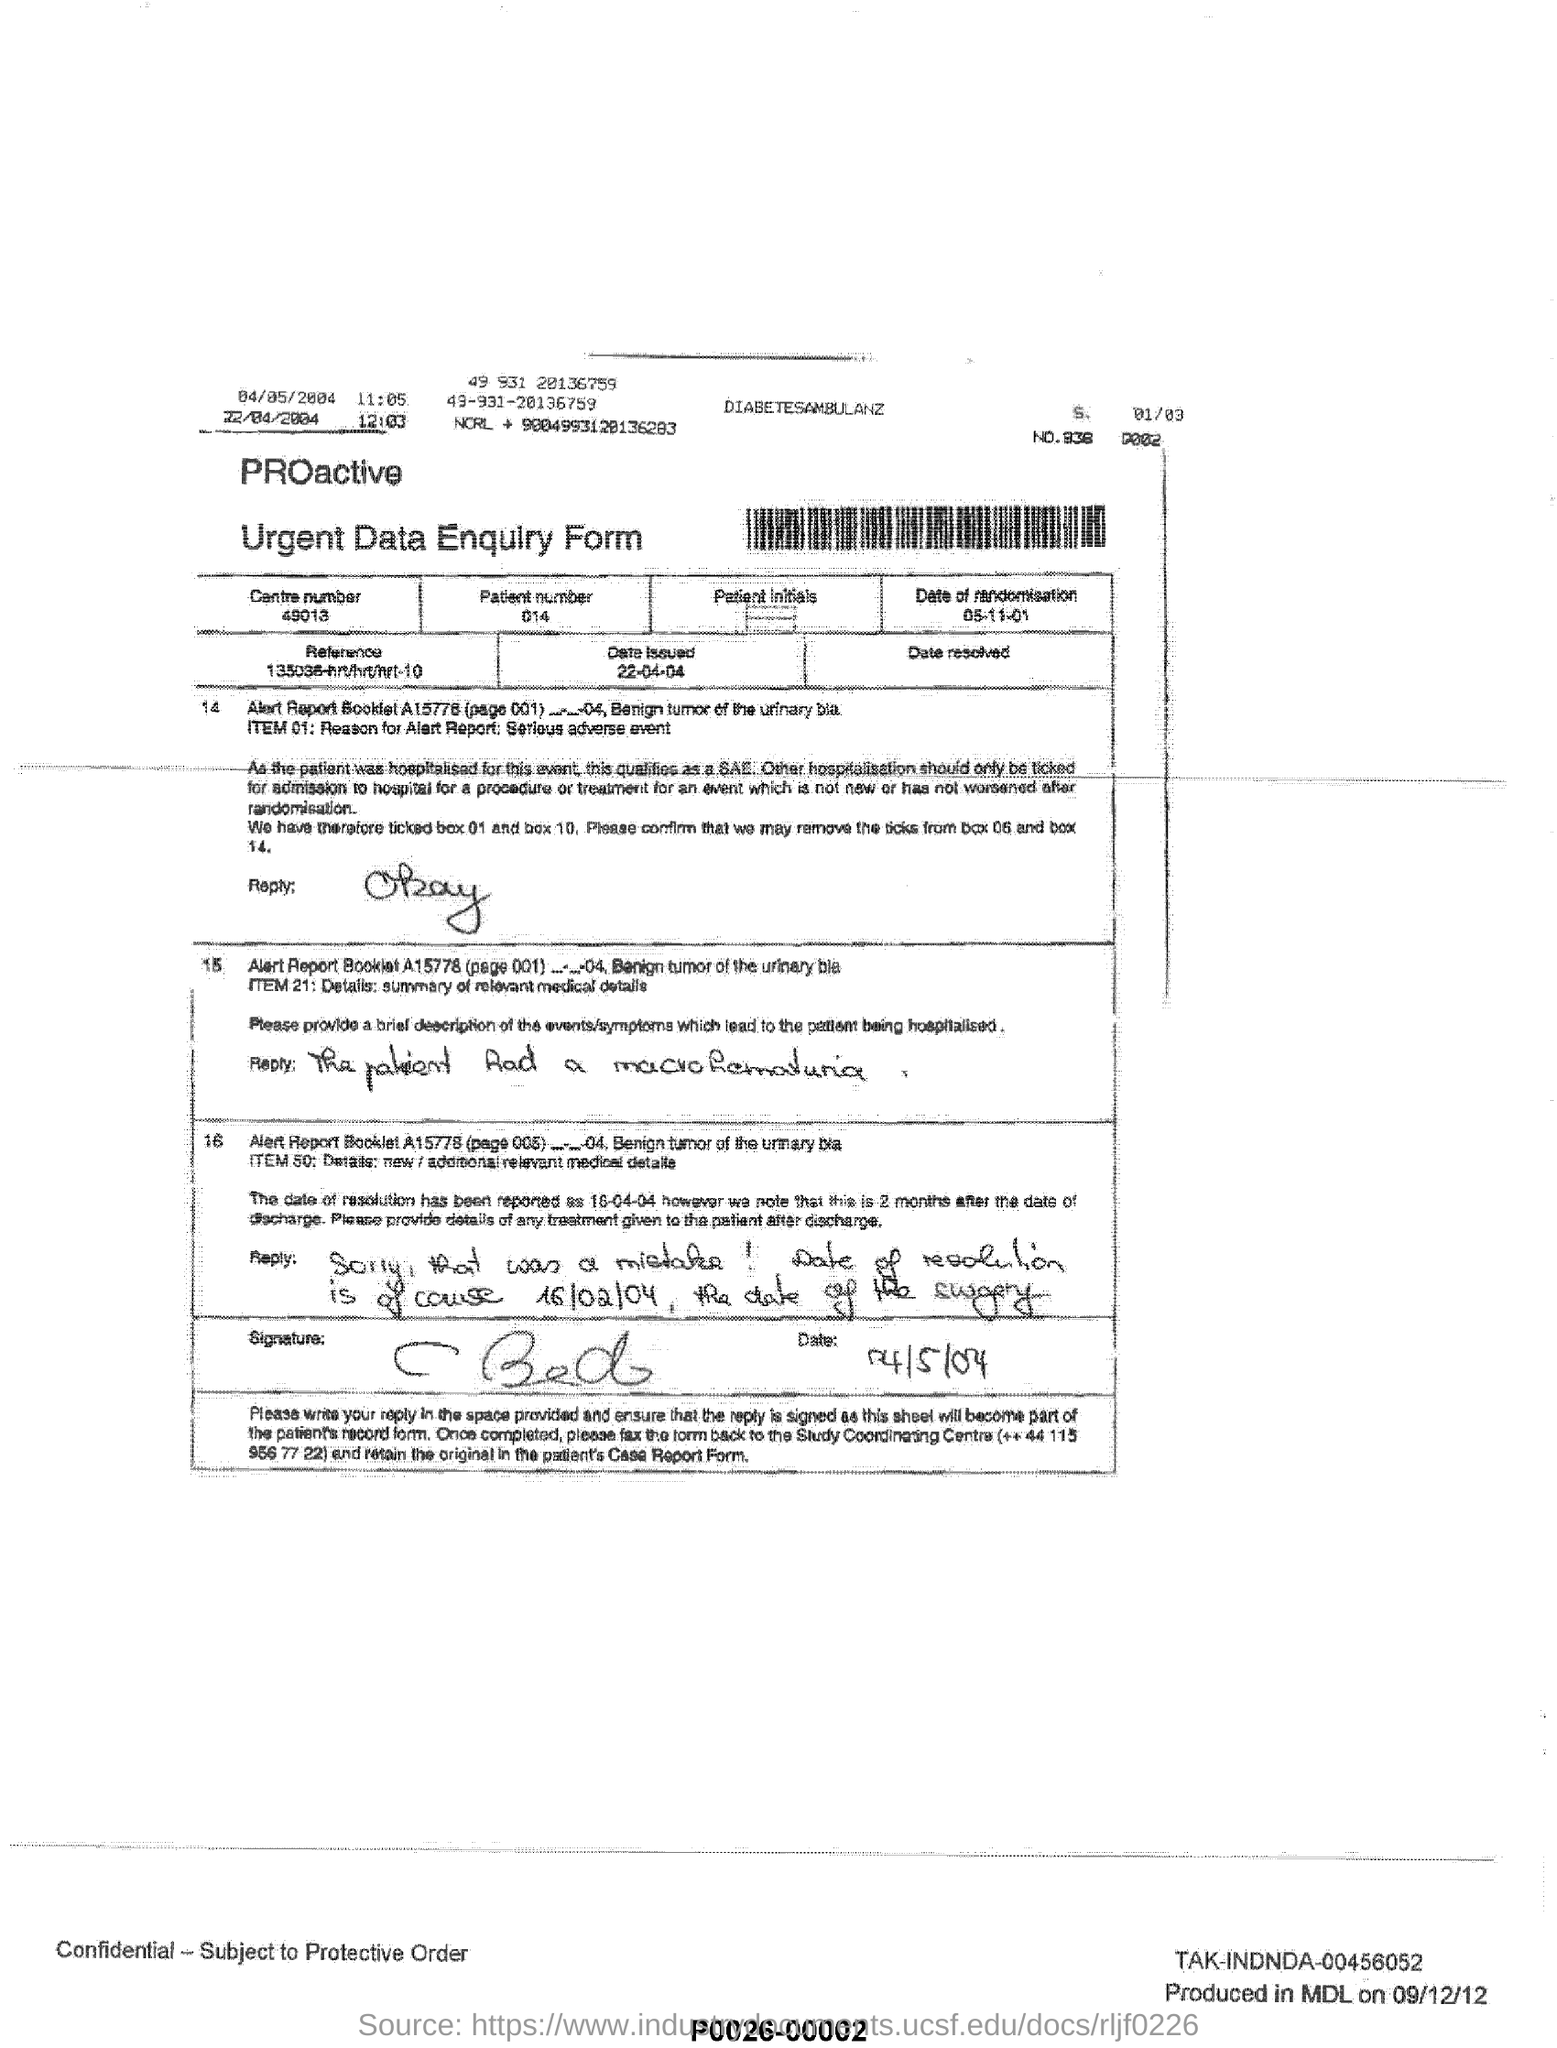What is the name of the form ?
Provide a short and direct response. Urgent data enquiry form. What is the centre number ?
Your answer should be very brief. 49013. What is the date issued mentioned in the form ?
Provide a succinct answer. 22-04-04. What is the patient number ?
Keep it short and to the point. 014. 